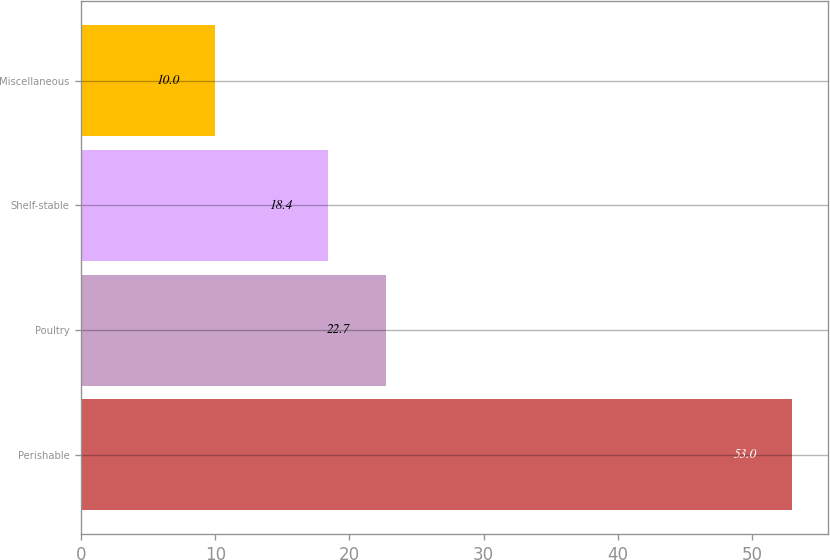<chart> <loc_0><loc_0><loc_500><loc_500><bar_chart><fcel>Perishable<fcel>Poultry<fcel>Shelf-stable<fcel>Miscellaneous<nl><fcel>53<fcel>22.7<fcel>18.4<fcel>10<nl></chart> 